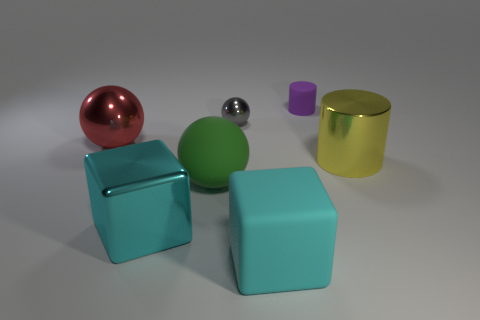Add 1 large brown metal blocks. How many objects exist? 8 Subtract all small gray balls. How many balls are left? 2 Subtract 1 balls. How many balls are left? 2 Subtract all green balls. How many balls are left? 2 Subtract all small yellow cylinders. Subtract all small purple cylinders. How many objects are left? 6 Add 5 large metallic cylinders. How many large metallic cylinders are left? 6 Add 1 tiny yellow shiny balls. How many tiny yellow shiny balls exist? 1 Subtract 1 red spheres. How many objects are left? 6 Subtract all cylinders. How many objects are left? 5 Subtract all blue cylinders. Subtract all green cubes. How many cylinders are left? 2 